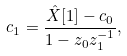<formula> <loc_0><loc_0><loc_500><loc_500>c _ { 1 } = { \frac { { \hat { X } } [ 1 ] - c _ { 0 } } { 1 - z _ { 0 } z _ { 1 } ^ { - 1 } } } ,</formula> 